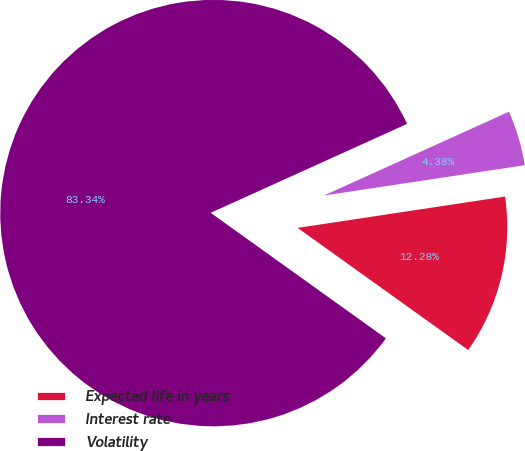Convert chart to OTSL. <chart><loc_0><loc_0><loc_500><loc_500><pie_chart><fcel>Expected life in years<fcel>Interest rate<fcel>Volatility<nl><fcel>12.28%<fcel>4.38%<fcel>83.34%<nl></chart> 